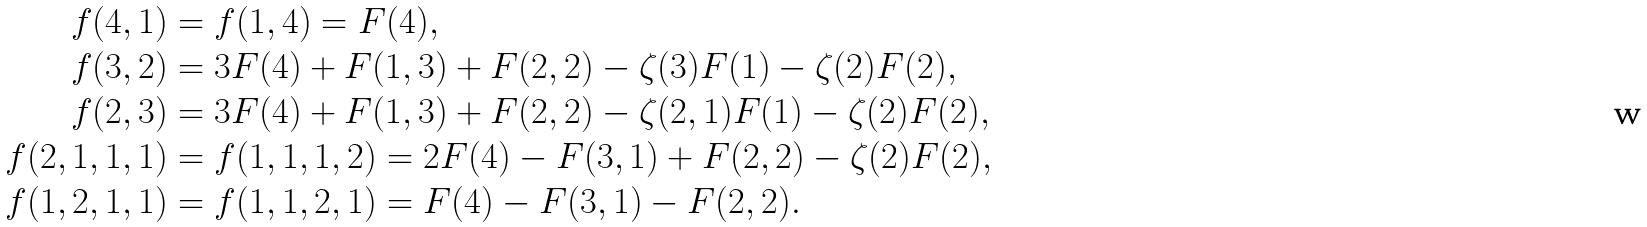Convert formula to latex. <formula><loc_0><loc_0><loc_500><loc_500>f ( 4 , 1 ) & = f ( 1 , 4 ) = F ( 4 ) , \\ f ( 3 , 2 ) & = 3 F ( 4 ) + F ( 1 , 3 ) + F ( 2 , 2 ) - \zeta ( 3 ) F ( 1 ) - \zeta ( 2 ) F ( 2 ) , \\ f ( 2 , 3 ) & = 3 F ( 4 ) + F ( 1 , 3 ) + F ( 2 , 2 ) - \zeta ( 2 , 1 ) F ( 1 ) - \zeta ( 2 ) F ( 2 ) , \\ f ( 2 , 1 , 1 , 1 ) & = f ( 1 , 1 , 1 , 2 ) = 2 F ( 4 ) - F ( 3 , 1 ) + F ( 2 , 2 ) - \zeta ( 2 ) F ( 2 ) , \\ f ( 1 , 2 , 1 , 1 ) & = f ( 1 , 1 , 2 , 1 ) = F ( 4 ) - F ( 3 , 1 ) - F ( 2 , 2 ) .</formula> 